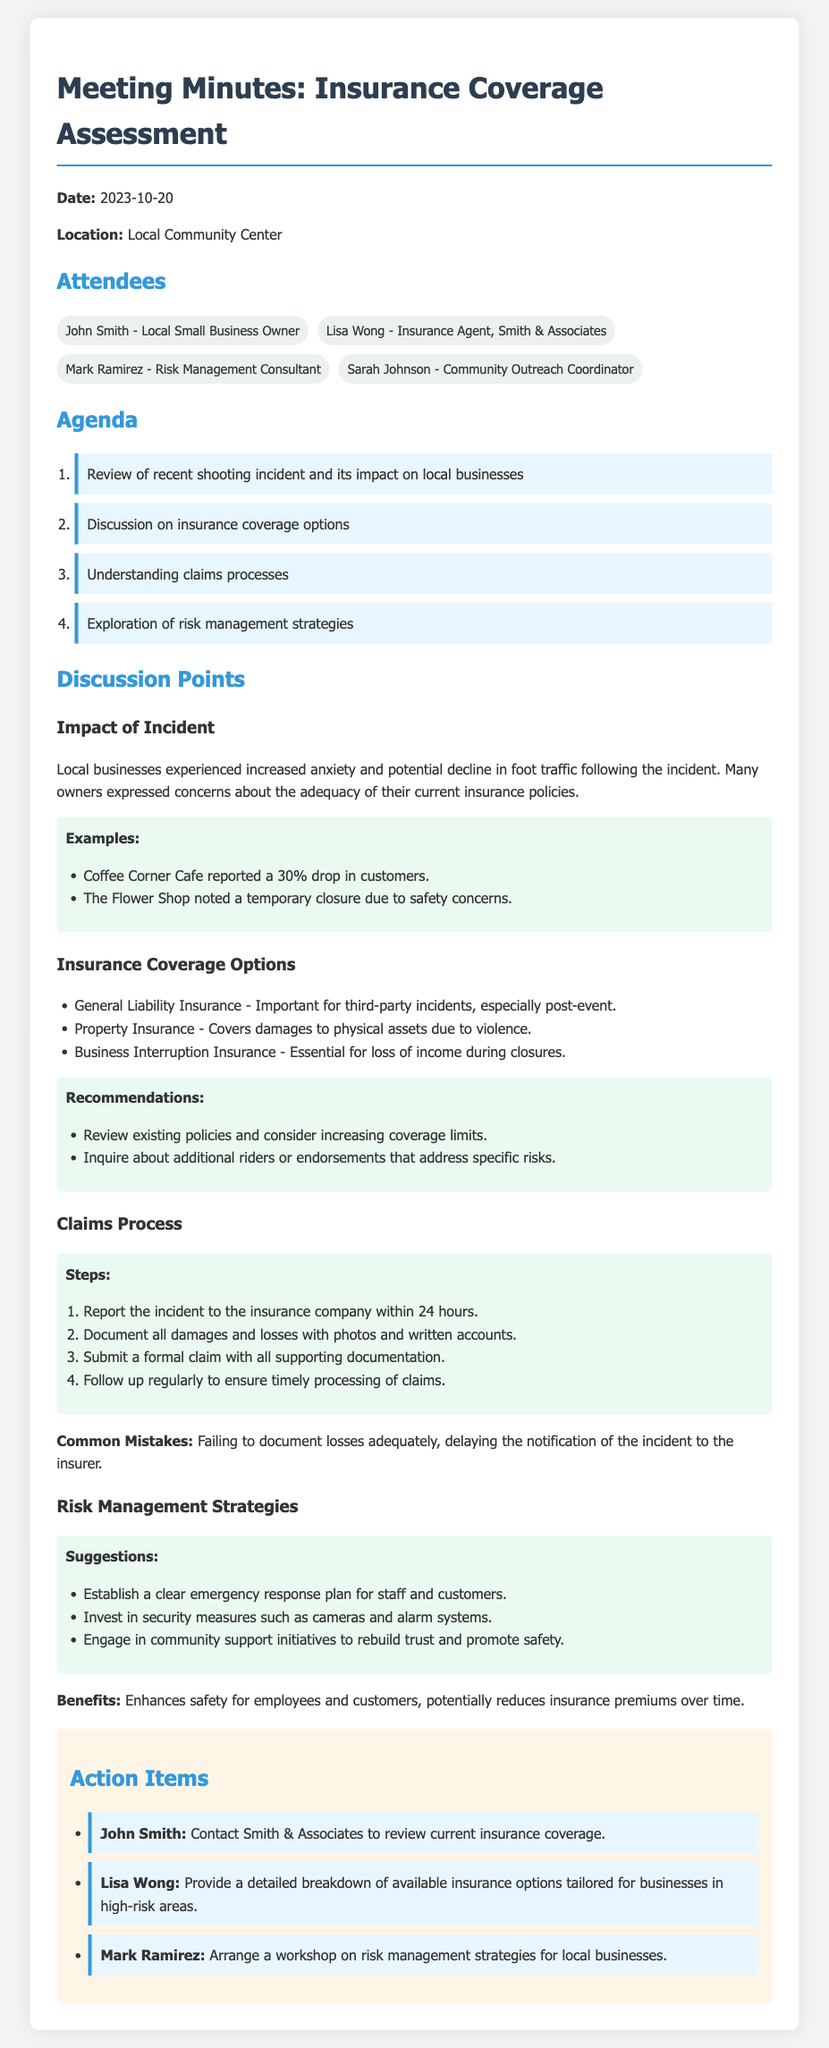What is the date of the meeting? The date of the meeting can be found in the document header.
Answer: 2023-10-20 Who is the insurance agent present at the meeting? The name of the insurance agent is listed in the attendees section.
Answer: Lisa Wong What is one type of insurance mentioned for covering property damages? The document lists various insurance types in the discussion on insurance coverage options.
Answer: Property Insurance What percentage drop in customers did Coffee Corner Cafe report? This information is mentioned under examples related to the impact of the incident.
Answer: 30% What is the first step in the claims process? The claims process is outlined in a specific section of the document.
Answer: Report the incident to the insurance company within 24 hours What is a suggestion offered for risk management strategies? Suggestions for risk management strategies are listed in the corresponding discussion point.
Answer: Establish a clear emergency response plan for staff and customers Who is responsible for providing a breakdown of available insurance options? This task can be found under action items at the end of the document.
Answer: Lisa Wong How many attendees are listed in the document? The number of attendees can be counted in the attendees section.
Answer: Four 